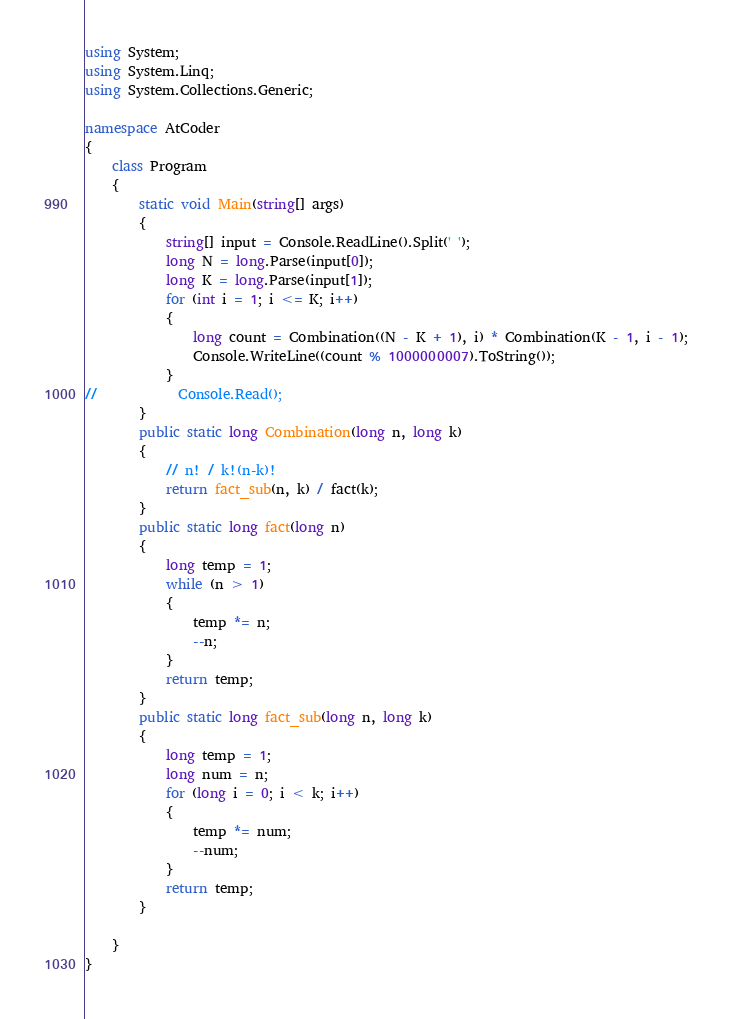Convert code to text. <code><loc_0><loc_0><loc_500><loc_500><_C#_>using System;
using System.Linq;
using System.Collections.Generic;

namespace AtCoder
{
    class Program
    {
        static void Main(string[] args)
        {
            string[] input = Console.ReadLine().Split(' ');
            long N = long.Parse(input[0]);
            long K = long.Parse(input[1]);
            for (int i = 1; i <= K; i++)
            {
                long count = Combination((N - K + 1), i) * Combination(K - 1, i - 1);
                Console.WriteLine((count % 1000000007).ToString());
            }
//            Console.Read();
        }
        public static long Combination(long n, long k)
        {
            // n! / k!(n-k)!
            return fact_sub(n, k) / fact(k);
        }
        public static long fact(long n)
        {
            long temp = 1;
            while (n > 1)
            {
                temp *= n;
                --n;
            }
            return temp;
        }
        public static long fact_sub(long n, long k)
        {
            long temp = 1;
            long num = n;
            for (long i = 0; i < k; i++)
            {
                temp *= num;
                --num;
            }
            return temp;
        }

    }
}   </code> 